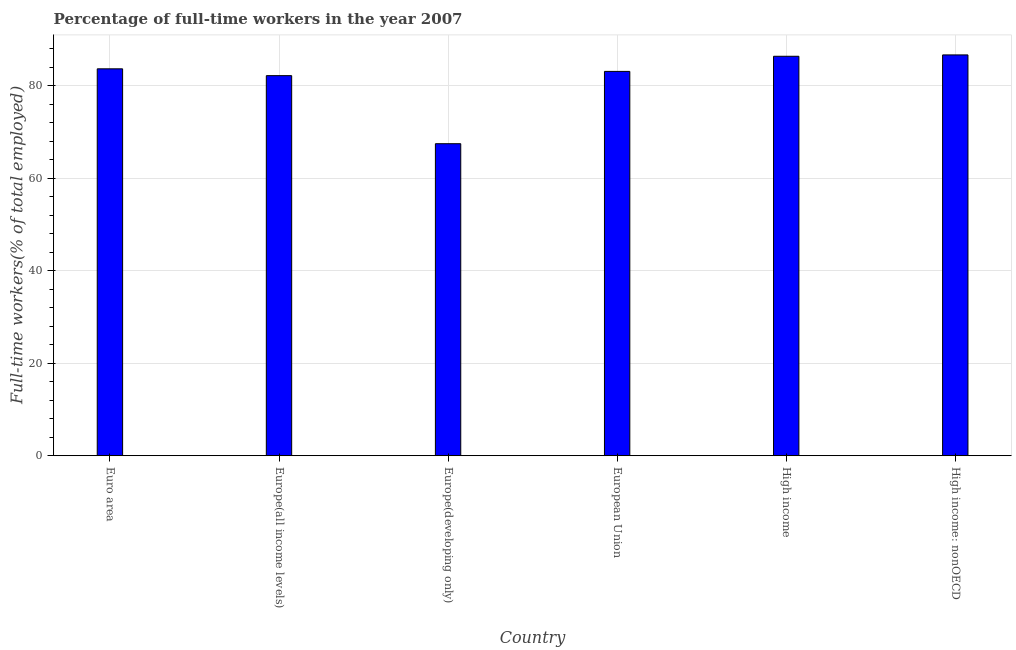Does the graph contain any zero values?
Your response must be concise. No. Does the graph contain grids?
Your answer should be compact. Yes. What is the title of the graph?
Keep it short and to the point. Percentage of full-time workers in the year 2007. What is the label or title of the X-axis?
Offer a terse response. Country. What is the label or title of the Y-axis?
Ensure brevity in your answer.  Full-time workers(% of total employed). What is the percentage of full-time workers in Euro area?
Keep it short and to the point. 83.66. Across all countries, what is the maximum percentage of full-time workers?
Offer a very short reply. 86.67. Across all countries, what is the minimum percentage of full-time workers?
Give a very brief answer. 67.47. In which country was the percentage of full-time workers maximum?
Keep it short and to the point. High income: nonOECD. In which country was the percentage of full-time workers minimum?
Provide a short and direct response. Europe(developing only). What is the sum of the percentage of full-time workers?
Your answer should be very brief. 489.47. What is the difference between the percentage of full-time workers in European Union and High income?
Your answer should be compact. -3.27. What is the average percentage of full-time workers per country?
Ensure brevity in your answer.  81.58. What is the median percentage of full-time workers?
Make the answer very short. 83.38. In how many countries, is the percentage of full-time workers greater than 44 %?
Provide a succinct answer. 6. What is the ratio of the percentage of full-time workers in Europe(developing only) to that in High income?
Make the answer very short. 0.78. Is the percentage of full-time workers in Euro area less than that in Europe(all income levels)?
Provide a short and direct response. No. Is the difference between the percentage of full-time workers in European Union and High income greater than the difference between any two countries?
Ensure brevity in your answer.  No. What is the difference between the highest and the second highest percentage of full-time workers?
Make the answer very short. 0.29. What is the difference between the highest and the lowest percentage of full-time workers?
Ensure brevity in your answer.  19.2. What is the Full-time workers(% of total employed) of Euro area?
Offer a very short reply. 83.66. What is the Full-time workers(% of total employed) of Europe(all income levels)?
Offer a very short reply. 82.19. What is the Full-time workers(% of total employed) in Europe(developing only)?
Provide a succinct answer. 67.47. What is the Full-time workers(% of total employed) in European Union?
Your answer should be very brief. 83.11. What is the Full-time workers(% of total employed) of High income?
Your response must be concise. 86.38. What is the Full-time workers(% of total employed) in High income: nonOECD?
Your answer should be very brief. 86.67. What is the difference between the Full-time workers(% of total employed) in Euro area and Europe(all income levels)?
Ensure brevity in your answer.  1.47. What is the difference between the Full-time workers(% of total employed) in Euro area and Europe(developing only)?
Your answer should be very brief. 16.19. What is the difference between the Full-time workers(% of total employed) in Euro area and European Union?
Provide a short and direct response. 0.56. What is the difference between the Full-time workers(% of total employed) in Euro area and High income?
Provide a short and direct response. -2.72. What is the difference between the Full-time workers(% of total employed) in Euro area and High income: nonOECD?
Give a very brief answer. -3.01. What is the difference between the Full-time workers(% of total employed) in Europe(all income levels) and Europe(developing only)?
Provide a succinct answer. 14.72. What is the difference between the Full-time workers(% of total employed) in Europe(all income levels) and European Union?
Your answer should be very brief. -0.92. What is the difference between the Full-time workers(% of total employed) in Europe(all income levels) and High income?
Make the answer very short. -4.19. What is the difference between the Full-time workers(% of total employed) in Europe(all income levels) and High income: nonOECD?
Provide a succinct answer. -4.48. What is the difference between the Full-time workers(% of total employed) in Europe(developing only) and European Union?
Ensure brevity in your answer.  -15.64. What is the difference between the Full-time workers(% of total employed) in Europe(developing only) and High income?
Make the answer very short. -18.91. What is the difference between the Full-time workers(% of total employed) in Europe(developing only) and High income: nonOECD?
Make the answer very short. -19.2. What is the difference between the Full-time workers(% of total employed) in European Union and High income?
Keep it short and to the point. -3.27. What is the difference between the Full-time workers(% of total employed) in European Union and High income: nonOECD?
Keep it short and to the point. -3.56. What is the difference between the Full-time workers(% of total employed) in High income and High income: nonOECD?
Your response must be concise. -0.29. What is the ratio of the Full-time workers(% of total employed) in Euro area to that in Europe(developing only)?
Provide a succinct answer. 1.24. What is the ratio of the Full-time workers(% of total employed) in Euro area to that in European Union?
Your response must be concise. 1.01. What is the ratio of the Full-time workers(% of total employed) in Euro area to that in High income?
Offer a very short reply. 0.97. What is the ratio of the Full-time workers(% of total employed) in Europe(all income levels) to that in Europe(developing only)?
Your answer should be very brief. 1.22. What is the ratio of the Full-time workers(% of total employed) in Europe(all income levels) to that in High income?
Ensure brevity in your answer.  0.95. What is the ratio of the Full-time workers(% of total employed) in Europe(all income levels) to that in High income: nonOECD?
Your response must be concise. 0.95. What is the ratio of the Full-time workers(% of total employed) in Europe(developing only) to that in European Union?
Make the answer very short. 0.81. What is the ratio of the Full-time workers(% of total employed) in Europe(developing only) to that in High income?
Your answer should be very brief. 0.78. What is the ratio of the Full-time workers(% of total employed) in Europe(developing only) to that in High income: nonOECD?
Your answer should be compact. 0.78. What is the ratio of the Full-time workers(% of total employed) in European Union to that in High income: nonOECD?
Offer a terse response. 0.96. What is the ratio of the Full-time workers(% of total employed) in High income to that in High income: nonOECD?
Provide a succinct answer. 1. 